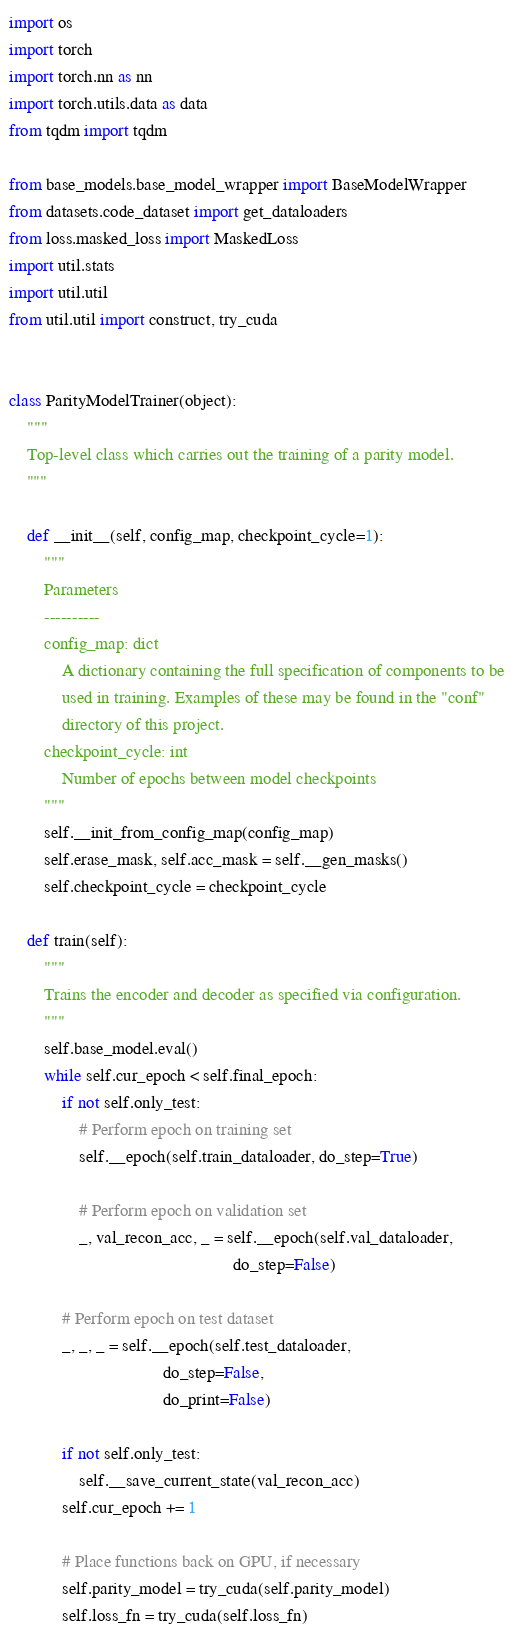Convert code to text. <code><loc_0><loc_0><loc_500><loc_500><_Python_>import os
import torch
import torch.nn as nn
import torch.utils.data as data
from tqdm import tqdm

from base_models.base_model_wrapper import BaseModelWrapper
from datasets.code_dataset import get_dataloaders
from loss.masked_loss import MaskedLoss
import util.stats
import util.util
from util.util import construct, try_cuda


class ParityModelTrainer(object):
    """
    Top-level class which carries out the training of a parity model.
    """

    def __init__(self, config_map, checkpoint_cycle=1):
        """
        Parameters
        ----------
        config_map: dict
            A dictionary containing the full specification of components to be
            used in training. Examples of these may be found in the "conf"
            directory of this project.
        checkpoint_cycle: int
            Number of epochs between model checkpoints
        """
        self.__init_from_config_map(config_map)
        self.erase_mask, self.acc_mask = self.__gen_masks()
        self.checkpoint_cycle = checkpoint_cycle

    def train(self):
        """
        Trains the encoder and decoder as specified via configuration.
        """
        self.base_model.eval()
        while self.cur_epoch < self.final_epoch:
            if not self.only_test:
                # Perform epoch on training set
                self.__epoch(self.train_dataloader, do_step=True)

                # Perform epoch on validation set
                _, val_recon_acc, _ = self.__epoch(self.val_dataloader,
                                                   do_step=False)

            # Perform epoch on test dataset
            _, _, _ = self.__epoch(self.test_dataloader,
                                   do_step=False,
                                   do_print=False)

            if not self.only_test:
                self.__save_current_state(val_recon_acc)
            self.cur_epoch += 1

            # Place functions back on GPU, if necessary
            self.parity_model = try_cuda(self.parity_model)
            self.loss_fn = try_cuda(self.loss_fn)
</code> 